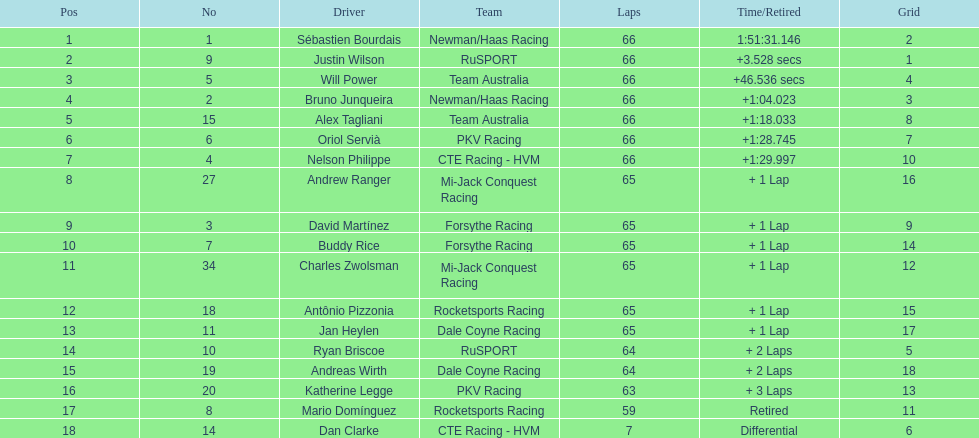What is the number of laps dan clarke completed? 7. 